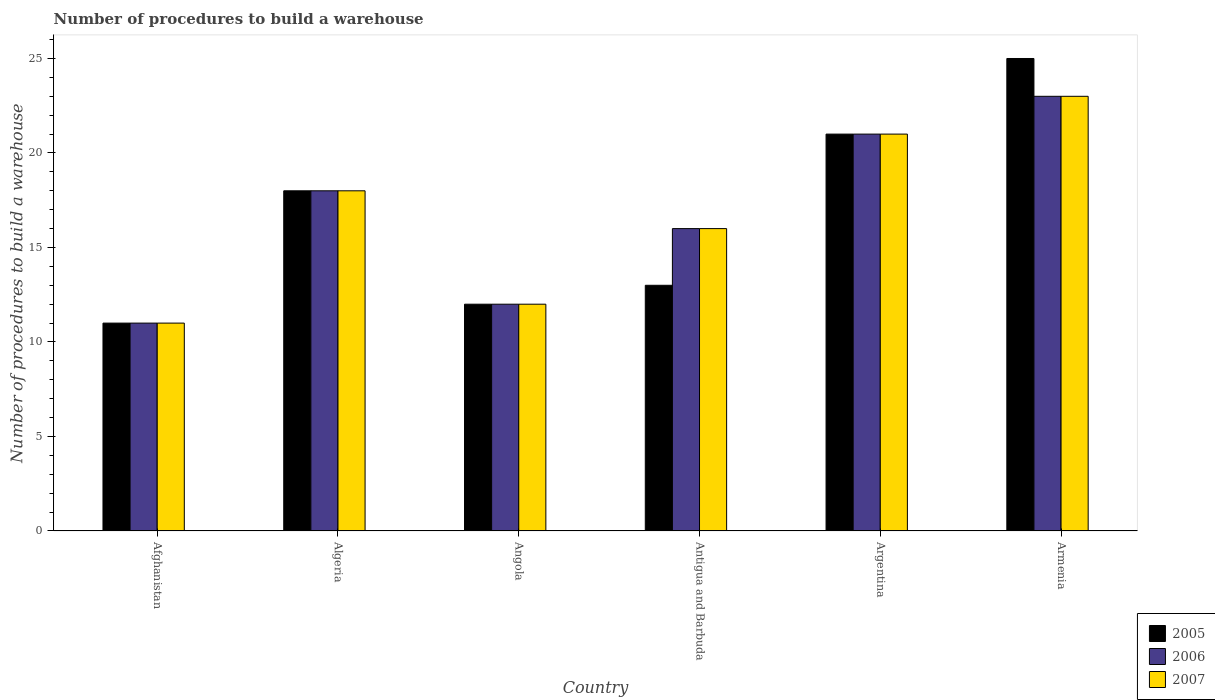How many different coloured bars are there?
Offer a very short reply. 3. How many groups of bars are there?
Offer a terse response. 6. Are the number of bars per tick equal to the number of legend labels?
Give a very brief answer. Yes. Are the number of bars on each tick of the X-axis equal?
Keep it short and to the point. Yes. How many bars are there on the 3rd tick from the left?
Your answer should be very brief. 3. What is the label of the 4th group of bars from the left?
Offer a terse response. Antigua and Barbuda. In how many cases, is the number of bars for a given country not equal to the number of legend labels?
Offer a very short reply. 0. What is the number of procedures to build a warehouse in in 2007 in Antigua and Barbuda?
Make the answer very short. 16. Across all countries, what is the maximum number of procedures to build a warehouse in in 2005?
Make the answer very short. 25. In which country was the number of procedures to build a warehouse in in 2005 maximum?
Your response must be concise. Armenia. In which country was the number of procedures to build a warehouse in in 2006 minimum?
Your answer should be very brief. Afghanistan. What is the total number of procedures to build a warehouse in in 2006 in the graph?
Your response must be concise. 101. What is the difference between the number of procedures to build a warehouse in in 2005 in Afghanistan and that in Armenia?
Ensure brevity in your answer.  -14. What is the average number of procedures to build a warehouse in in 2005 per country?
Provide a short and direct response. 16.67. What is the difference between the number of procedures to build a warehouse in of/in 2005 and number of procedures to build a warehouse in of/in 2007 in Algeria?
Keep it short and to the point. 0. In how many countries, is the number of procedures to build a warehouse in in 2007 greater than 22?
Keep it short and to the point. 1. What is the ratio of the number of procedures to build a warehouse in in 2005 in Algeria to that in Armenia?
Your answer should be compact. 0.72. Is the number of procedures to build a warehouse in in 2006 in Afghanistan less than that in Armenia?
Keep it short and to the point. Yes. Is the difference between the number of procedures to build a warehouse in in 2005 in Afghanistan and Angola greater than the difference between the number of procedures to build a warehouse in in 2007 in Afghanistan and Angola?
Provide a succinct answer. No. What is the difference between the highest and the second highest number of procedures to build a warehouse in in 2006?
Ensure brevity in your answer.  -3. What is the difference between the highest and the lowest number of procedures to build a warehouse in in 2006?
Give a very brief answer. 12. Is the sum of the number of procedures to build a warehouse in in 2007 in Afghanistan and Angola greater than the maximum number of procedures to build a warehouse in in 2005 across all countries?
Give a very brief answer. No. What does the 3rd bar from the left in Armenia represents?
Provide a succinct answer. 2007. How many bars are there?
Your response must be concise. 18. Are the values on the major ticks of Y-axis written in scientific E-notation?
Your response must be concise. No. Does the graph contain any zero values?
Your response must be concise. No. How are the legend labels stacked?
Offer a terse response. Vertical. What is the title of the graph?
Make the answer very short. Number of procedures to build a warehouse. What is the label or title of the X-axis?
Offer a very short reply. Country. What is the label or title of the Y-axis?
Provide a short and direct response. Number of procedures to build a warehouse. What is the Number of procedures to build a warehouse of 2005 in Algeria?
Your answer should be very brief. 18. What is the Number of procedures to build a warehouse of 2006 in Angola?
Make the answer very short. 12. What is the Number of procedures to build a warehouse of 2007 in Angola?
Provide a succinct answer. 12. What is the Number of procedures to build a warehouse in 2005 in Antigua and Barbuda?
Offer a terse response. 13. What is the Number of procedures to build a warehouse of 2006 in Antigua and Barbuda?
Provide a succinct answer. 16. What is the Number of procedures to build a warehouse in 2007 in Antigua and Barbuda?
Offer a terse response. 16. What is the Number of procedures to build a warehouse in 2005 in Argentina?
Provide a succinct answer. 21. What is the Number of procedures to build a warehouse of 2006 in Argentina?
Your response must be concise. 21. What is the Number of procedures to build a warehouse in 2007 in Argentina?
Give a very brief answer. 21. What is the Number of procedures to build a warehouse of 2007 in Armenia?
Make the answer very short. 23. Across all countries, what is the minimum Number of procedures to build a warehouse of 2006?
Your answer should be compact. 11. Across all countries, what is the minimum Number of procedures to build a warehouse of 2007?
Ensure brevity in your answer.  11. What is the total Number of procedures to build a warehouse of 2006 in the graph?
Your response must be concise. 101. What is the total Number of procedures to build a warehouse in 2007 in the graph?
Offer a terse response. 101. What is the difference between the Number of procedures to build a warehouse of 2006 in Afghanistan and that in Algeria?
Keep it short and to the point. -7. What is the difference between the Number of procedures to build a warehouse in 2007 in Afghanistan and that in Angola?
Keep it short and to the point. -1. What is the difference between the Number of procedures to build a warehouse in 2005 in Afghanistan and that in Antigua and Barbuda?
Keep it short and to the point. -2. What is the difference between the Number of procedures to build a warehouse in 2005 in Afghanistan and that in Argentina?
Offer a very short reply. -10. What is the difference between the Number of procedures to build a warehouse in 2006 in Afghanistan and that in Armenia?
Offer a very short reply. -12. What is the difference between the Number of procedures to build a warehouse of 2007 in Afghanistan and that in Armenia?
Your response must be concise. -12. What is the difference between the Number of procedures to build a warehouse of 2005 in Algeria and that in Angola?
Your response must be concise. 6. What is the difference between the Number of procedures to build a warehouse in 2006 in Algeria and that in Antigua and Barbuda?
Your response must be concise. 2. What is the difference between the Number of procedures to build a warehouse in 2007 in Algeria and that in Armenia?
Offer a terse response. -5. What is the difference between the Number of procedures to build a warehouse of 2005 in Angola and that in Antigua and Barbuda?
Offer a terse response. -1. What is the difference between the Number of procedures to build a warehouse of 2007 in Angola and that in Antigua and Barbuda?
Your answer should be compact. -4. What is the difference between the Number of procedures to build a warehouse of 2005 in Angola and that in Armenia?
Your answer should be compact. -13. What is the difference between the Number of procedures to build a warehouse of 2006 in Angola and that in Armenia?
Ensure brevity in your answer.  -11. What is the difference between the Number of procedures to build a warehouse of 2007 in Angola and that in Armenia?
Ensure brevity in your answer.  -11. What is the difference between the Number of procedures to build a warehouse of 2006 in Argentina and that in Armenia?
Offer a terse response. -2. What is the difference between the Number of procedures to build a warehouse of 2005 in Afghanistan and the Number of procedures to build a warehouse of 2006 in Algeria?
Your response must be concise. -7. What is the difference between the Number of procedures to build a warehouse in 2005 in Afghanistan and the Number of procedures to build a warehouse in 2007 in Algeria?
Your answer should be compact. -7. What is the difference between the Number of procedures to build a warehouse of 2006 in Afghanistan and the Number of procedures to build a warehouse of 2007 in Algeria?
Ensure brevity in your answer.  -7. What is the difference between the Number of procedures to build a warehouse of 2005 in Afghanistan and the Number of procedures to build a warehouse of 2007 in Angola?
Provide a succinct answer. -1. What is the difference between the Number of procedures to build a warehouse of 2005 in Afghanistan and the Number of procedures to build a warehouse of 2006 in Antigua and Barbuda?
Give a very brief answer. -5. What is the difference between the Number of procedures to build a warehouse in 2006 in Afghanistan and the Number of procedures to build a warehouse in 2007 in Antigua and Barbuda?
Offer a terse response. -5. What is the difference between the Number of procedures to build a warehouse in 2005 in Afghanistan and the Number of procedures to build a warehouse in 2006 in Argentina?
Give a very brief answer. -10. What is the difference between the Number of procedures to build a warehouse in 2005 in Afghanistan and the Number of procedures to build a warehouse in 2007 in Argentina?
Your answer should be compact. -10. What is the difference between the Number of procedures to build a warehouse in 2006 in Afghanistan and the Number of procedures to build a warehouse in 2007 in Argentina?
Ensure brevity in your answer.  -10. What is the difference between the Number of procedures to build a warehouse of 2005 in Afghanistan and the Number of procedures to build a warehouse of 2006 in Armenia?
Ensure brevity in your answer.  -12. What is the difference between the Number of procedures to build a warehouse of 2005 in Afghanistan and the Number of procedures to build a warehouse of 2007 in Armenia?
Offer a very short reply. -12. What is the difference between the Number of procedures to build a warehouse of 2006 in Algeria and the Number of procedures to build a warehouse of 2007 in Angola?
Make the answer very short. 6. What is the difference between the Number of procedures to build a warehouse in 2005 in Algeria and the Number of procedures to build a warehouse in 2006 in Antigua and Barbuda?
Offer a terse response. 2. What is the difference between the Number of procedures to build a warehouse of 2006 in Algeria and the Number of procedures to build a warehouse of 2007 in Antigua and Barbuda?
Keep it short and to the point. 2. What is the difference between the Number of procedures to build a warehouse in 2005 in Algeria and the Number of procedures to build a warehouse in 2006 in Argentina?
Your answer should be very brief. -3. What is the difference between the Number of procedures to build a warehouse in 2006 in Algeria and the Number of procedures to build a warehouse in 2007 in Argentina?
Ensure brevity in your answer.  -3. What is the difference between the Number of procedures to build a warehouse in 2006 in Algeria and the Number of procedures to build a warehouse in 2007 in Armenia?
Offer a terse response. -5. What is the difference between the Number of procedures to build a warehouse of 2005 in Angola and the Number of procedures to build a warehouse of 2007 in Antigua and Barbuda?
Your answer should be compact. -4. What is the difference between the Number of procedures to build a warehouse of 2006 in Angola and the Number of procedures to build a warehouse of 2007 in Antigua and Barbuda?
Provide a succinct answer. -4. What is the difference between the Number of procedures to build a warehouse of 2006 in Angola and the Number of procedures to build a warehouse of 2007 in Armenia?
Your answer should be compact. -11. What is the difference between the Number of procedures to build a warehouse in 2005 in Antigua and Barbuda and the Number of procedures to build a warehouse in 2007 in Argentina?
Your answer should be very brief. -8. What is the difference between the Number of procedures to build a warehouse of 2005 in Antigua and Barbuda and the Number of procedures to build a warehouse of 2006 in Armenia?
Provide a short and direct response. -10. What is the difference between the Number of procedures to build a warehouse in 2005 in Antigua and Barbuda and the Number of procedures to build a warehouse in 2007 in Armenia?
Provide a short and direct response. -10. What is the difference between the Number of procedures to build a warehouse of 2006 in Antigua and Barbuda and the Number of procedures to build a warehouse of 2007 in Armenia?
Your answer should be compact. -7. What is the average Number of procedures to build a warehouse of 2005 per country?
Keep it short and to the point. 16.67. What is the average Number of procedures to build a warehouse in 2006 per country?
Provide a short and direct response. 16.83. What is the average Number of procedures to build a warehouse in 2007 per country?
Make the answer very short. 16.83. What is the difference between the Number of procedures to build a warehouse of 2005 and Number of procedures to build a warehouse of 2006 in Afghanistan?
Make the answer very short. 0. What is the difference between the Number of procedures to build a warehouse of 2005 and Number of procedures to build a warehouse of 2007 in Afghanistan?
Offer a terse response. 0. What is the difference between the Number of procedures to build a warehouse in 2006 and Number of procedures to build a warehouse in 2007 in Afghanistan?
Your response must be concise. 0. What is the difference between the Number of procedures to build a warehouse of 2005 and Number of procedures to build a warehouse of 2006 in Algeria?
Offer a very short reply. 0. What is the difference between the Number of procedures to build a warehouse of 2005 and Number of procedures to build a warehouse of 2007 in Algeria?
Provide a short and direct response. 0. What is the difference between the Number of procedures to build a warehouse of 2006 and Number of procedures to build a warehouse of 2007 in Algeria?
Your answer should be compact. 0. What is the difference between the Number of procedures to build a warehouse of 2005 and Number of procedures to build a warehouse of 2006 in Angola?
Provide a succinct answer. 0. What is the difference between the Number of procedures to build a warehouse of 2005 and Number of procedures to build a warehouse of 2007 in Angola?
Give a very brief answer. 0. What is the difference between the Number of procedures to build a warehouse in 2005 and Number of procedures to build a warehouse in 2007 in Argentina?
Provide a succinct answer. 0. What is the difference between the Number of procedures to build a warehouse in 2005 and Number of procedures to build a warehouse in 2006 in Armenia?
Offer a very short reply. 2. What is the difference between the Number of procedures to build a warehouse of 2005 and Number of procedures to build a warehouse of 2007 in Armenia?
Give a very brief answer. 2. What is the ratio of the Number of procedures to build a warehouse of 2005 in Afghanistan to that in Algeria?
Provide a succinct answer. 0.61. What is the ratio of the Number of procedures to build a warehouse of 2006 in Afghanistan to that in Algeria?
Provide a succinct answer. 0.61. What is the ratio of the Number of procedures to build a warehouse of 2007 in Afghanistan to that in Algeria?
Ensure brevity in your answer.  0.61. What is the ratio of the Number of procedures to build a warehouse of 2005 in Afghanistan to that in Angola?
Give a very brief answer. 0.92. What is the ratio of the Number of procedures to build a warehouse of 2007 in Afghanistan to that in Angola?
Offer a terse response. 0.92. What is the ratio of the Number of procedures to build a warehouse in 2005 in Afghanistan to that in Antigua and Barbuda?
Your response must be concise. 0.85. What is the ratio of the Number of procedures to build a warehouse in 2006 in Afghanistan to that in Antigua and Barbuda?
Provide a succinct answer. 0.69. What is the ratio of the Number of procedures to build a warehouse in 2007 in Afghanistan to that in Antigua and Barbuda?
Offer a terse response. 0.69. What is the ratio of the Number of procedures to build a warehouse in 2005 in Afghanistan to that in Argentina?
Provide a succinct answer. 0.52. What is the ratio of the Number of procedures to build a warehouse of 2006 in Afghanistan to that in Argentina?
Your response must be concise. 0.52. What is the ratio of the Number of procedures to build a warehouse of 2007 in Afghanistan to that in Argentina?
Your answer should be very brief. 0.52. What is the ratio of the Number of procedures to build a warehouse in 2005 in Afghanistan to that in Armenia?
Offer a very short reply. 0.44. What is the ratio of the Number of procedures to build a warehouse of 2006 in Afghanistan to that in Armenia?
Provide a short and direct response. 0.48. What is the ratio of the Number of procedures to build a warehouse of 2007 in Afghanistan to that in Armenia?
Your answer should be compact. 0.48. What is the ratio of the Number of procedures to build a warehouse of 2007 in Algeria to that in Angola?
Provide a succinct answer. 1.5. What is the ratio of the Number of procedures to build a warehouse in 2005 in Algeria to that in Antigua and Barbuda?
Offer a terse response. 1.38. What is the ratio of the Number of procedures to build a warehouse in 2005 in Algeria to that in Argentina?
Ensure brevity in your answer.  0.86. What is the ratio of the Number of procedures to build a warehouse in 2006 in Algeria to that in Argentina?
Offer a terse response. 0.86. What is the ratio of the Number of procedures to build a warehouse of 2007 in Algeria to that in Argentina?
Your answer should be very brief. 0.86. What is the ratio of the Number of procedures to build a warehouse in 2005 in Algeria to that in Armenia?
Offer a very short reply. 0.72. What is the ratio of the Number of procedures to build a warehouse in 2006 in Algeria to that in Armenia?
Keep it short and to the point. 0.78. What is the ratio of the Number of procedures to build a warehouse of 2007 in Algeria to that in Armenia?
Your answer should be very brief. 0.78. What is the ratio of the Number of procedures to build a warehouse of 2005 in Angola to that in Antigua and Barbuda?
Ensure brevity in your answer.  0.92. What is the ratio of the Number of procedures to build a warehouse of 2006 in Angola to that in Antigua and Barbuda?
Your answer should be very brief. 0.75. What is the ratio of the Number of procedures to build a warehouse of 2007 in Angola to that in Antigua and Barbuda?
Offer a terse response. 0.75. What is the ratio of the Number of procedures to build a warehouse in 2005 in Angola to that in Argentina?
Ensure brevity in your answer.  0.57. What is the ratio of the Number of procedures to build a warehouse in 2007 in Angola to that in Argentina?
Your answer should be very brief. 0.57. What is the ratio of the Number of procedures to build a warehouse of 2005 in Angola to that in Armenia?
Offer a very short reply. 0.48. What is the ratio of the Number of procedures to build a warehouse in 2006 in Angola to that in Armenia?
Offer a very short reply. 0.52. What is the ratio of the Number of procedures to build a warehouse in 2007 in Angola to that in Armenia?
Keep it short and to the point. 0.52. What is the ratio of the Number of procedures to build a warehouse of 2005 in Antigua and Barbuda to that in Argentina?
Your answer should be very brief. 0.62. What is the ratio of the Number of procedures to build a warehouse of 2006 in Antigua and Barbuda to that in Argentina?
Keep it short and to the point. 0.76. What is the ratio of the Number of procedures to build a warehouse in 2007 in Antigua and Barbuda to that in Argentina?
Provide a short and direct response. 0.76. What is the ratio of the Number of procedures to build a warehouse in 2005 in Antigua and Barbuda to that in Armenia?
Ensure brevity in your answer.  0.52. What is the ratio of the Number of procedures to build a warehouse in 2006 in Antigua and Barbuda to that in Armenia?
Give a very brief answer. 0.7. What is the ratio of the Number of procedures to build a warehouse of 2007 in Antigua and Barbuda to that in Armenia?
Offer a terse response. 0.7. What is the ratio of the Number of procedures to build a warehouse of 2005 in Argentina to that in Armenia?
Your response must be concise. 0.84. What is the difference between the highest and the second highest Number of procedures to build a warehouse in 2005?
Offer a very short reply. 4. What is the difference between the highest and the second highest Number of procedures to build a warehouse of 2006?
Give a very brief answer. 2. What is the difference between the highest and the lowest Number of procedures to build a warehouse in 2006?
Offer a terse response. 12. 